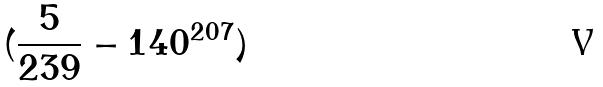<formula> <loc_0><loc_0><loc_500><loc_500>( \frac { 5 } { 2 3 9 } - 1 4 0 ^ { 2 0 7 } )</formula> 